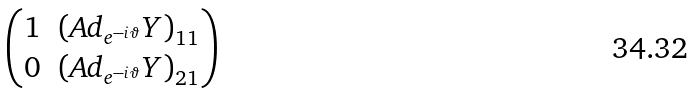Convert formula to latex. <formula><loc_0><loc_0><loc_500><loc_500>\begin{pmatrix} 1 & \left ( A d _ { e ^ { - i \vartheta } } Y \right ) _ { 1 1 } \\ 0 & \left ( A d _ { e ^ { - i \vartheta } } Y \right ) _ { 2 1 } \end{pmatrix}</formula> 